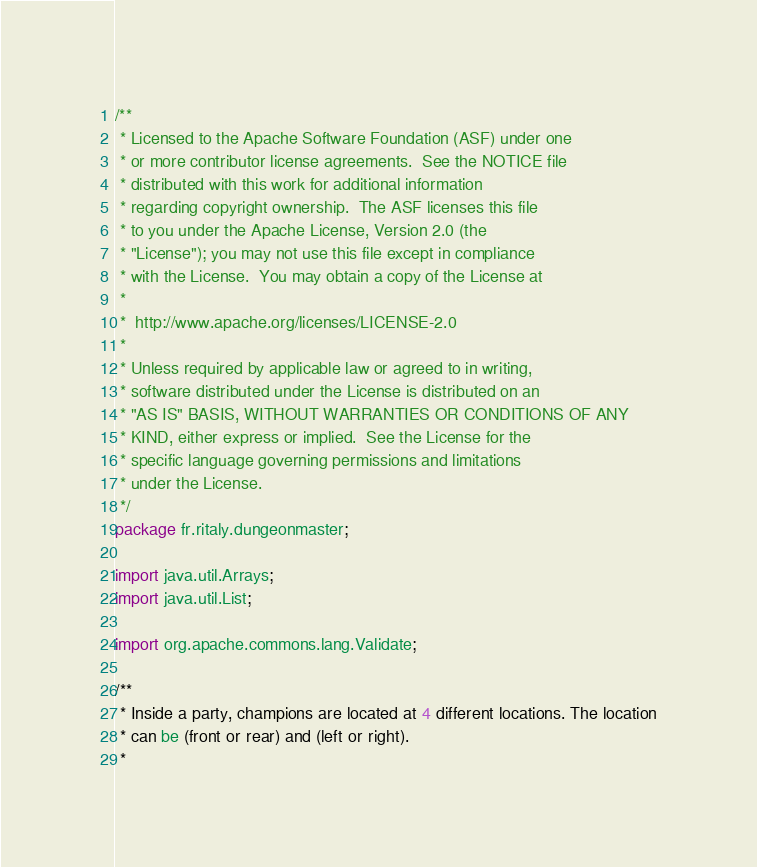Convert code to text. <code><loc_0><loc_0><loc_500><loc_500><_Java_>/**
 * Licensed to the Apache Software Foundation (ASF) under one
 * or more contributor license agreements.  See the NOTICE file
 * distributed with this work for additional information
 * regarding copyright ownership.  The ASF licenses this file
 * to you under the Apache License, Version 2.0 (the
 * "License"); you may not use this file except in compliance
 * with the License.  You may obtain a copy of the License at
 *
 *  http://www.apache.org/licenses/LICENSE-2.0
 *
 * Unless required by applicable law or agreed to in writing,
 * software distributed under the License is distributed on an
 * "AS IS" BASIS, WITHOUT WARRANTIES OR CONDITIONS OF ANY
 * KIND, either express or implied.  See the License for the
 * specific language governing permissions and limitations
 * under the License.
 */
package fr.ritaly.dungeonmaster;

import java.util.Arrays;
import java.util.List;

import org.apache.commons.lang.Validate;

/**
 * Inside a party, champions are located at 4 different locations. The location
 * can be (front or rear) and (left or right).
 *</code> 